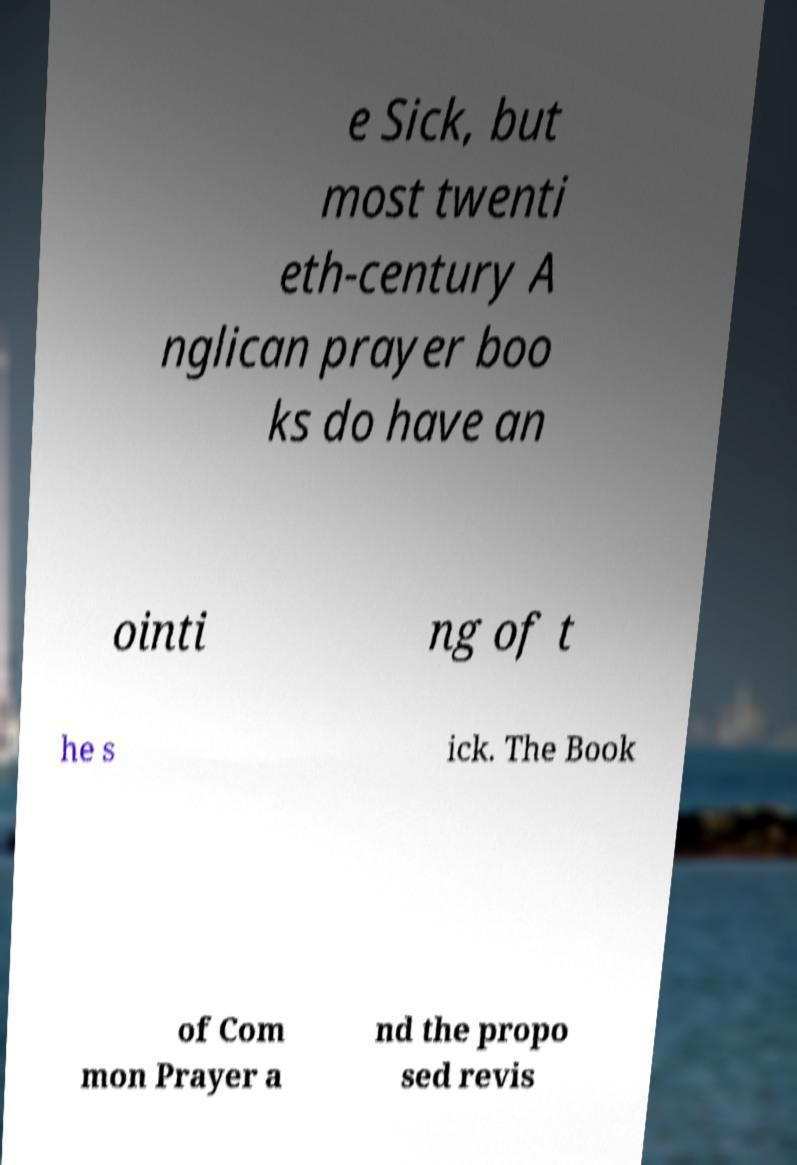Could you extract and type out the text from this image? e Sick, but most twenti eth-century A nglican prayer boo ks do have an ointi ng of t he s ick. The Book of Com mon Prayer a nd the propo sed revis 